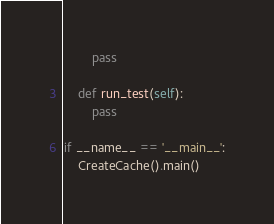Convert code to text. <code><loc_0><loc_0><loc_500><loc_500><_Python_>        pass

    def run_test(self):
        pass

if __name__ == '__main__':
    CreateCache().main()
</code> 